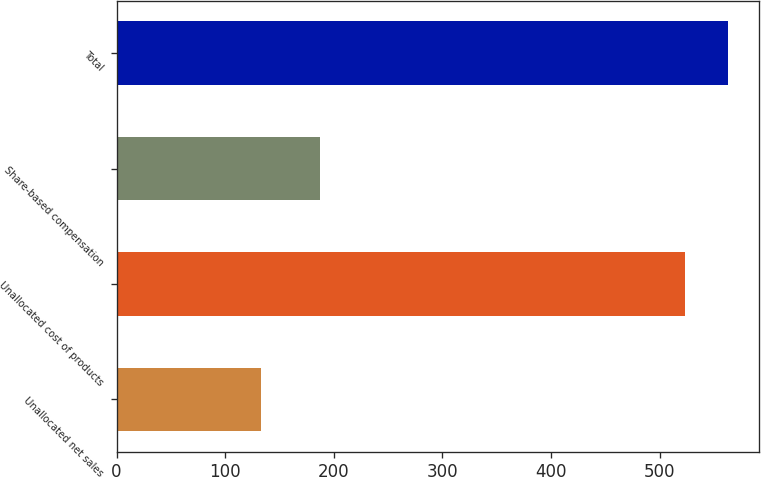Convert chart to OTSL. <chart><loc_0><loc_0><loc_500><loc_500><bar_chart><fcel>Unallocated net sales<fcel>Unallocated cost of products<fcel>Share-based compensation<fcel>Total<nl><fcel>133<fcel>523<fcel>187<fcel>563.5<nl></chart> 